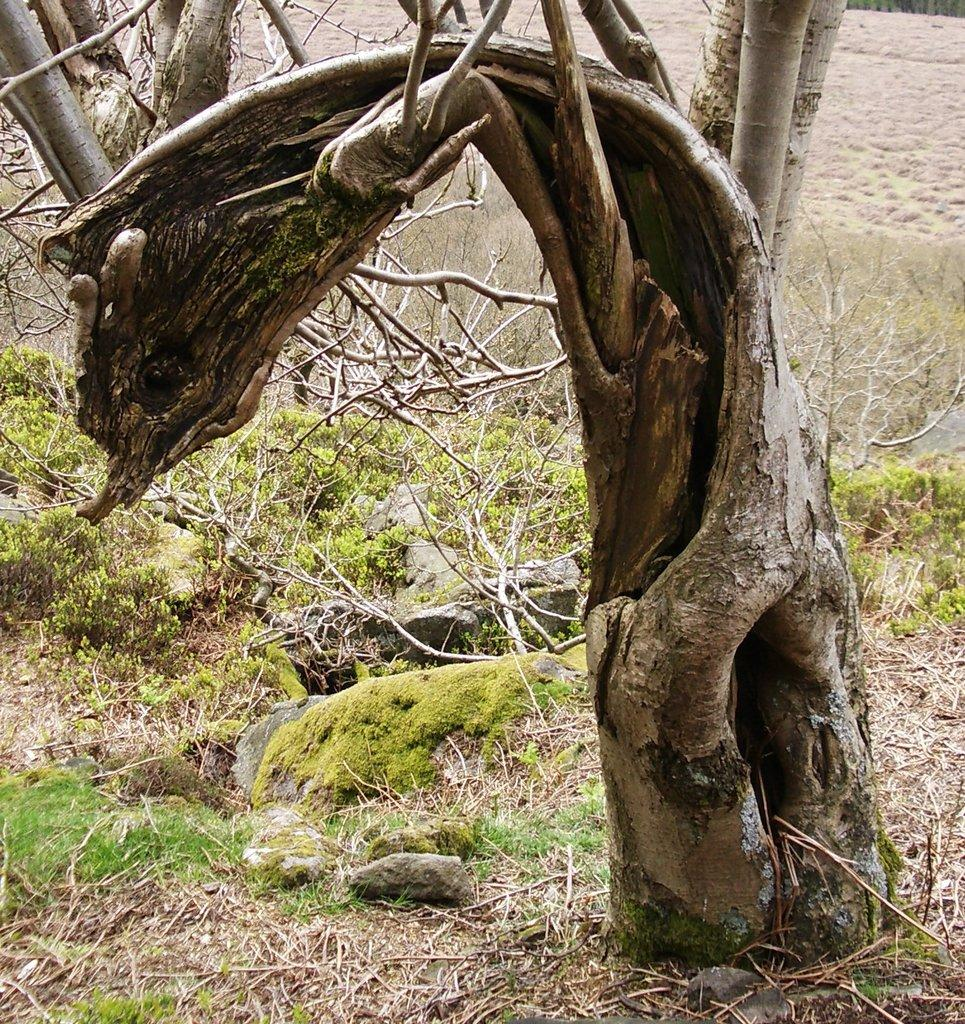What type of vegetation is on the right side of the image? There is a tree on the right side of the image. What type of ground cover is present in the image? There is grass in the image. What can be seen on the ground in the image? There are stones on the ground in the image. What is visible in the background of the image? There are trees and dry land visible in the background of the image. What color is the crayon on the tree in the image? There is no crayon present in the image; it is a tree with no crayons attached to it. How many cobwebs can be seen on the stones in the image? There are no cobwebs visible on the stones in the image. 